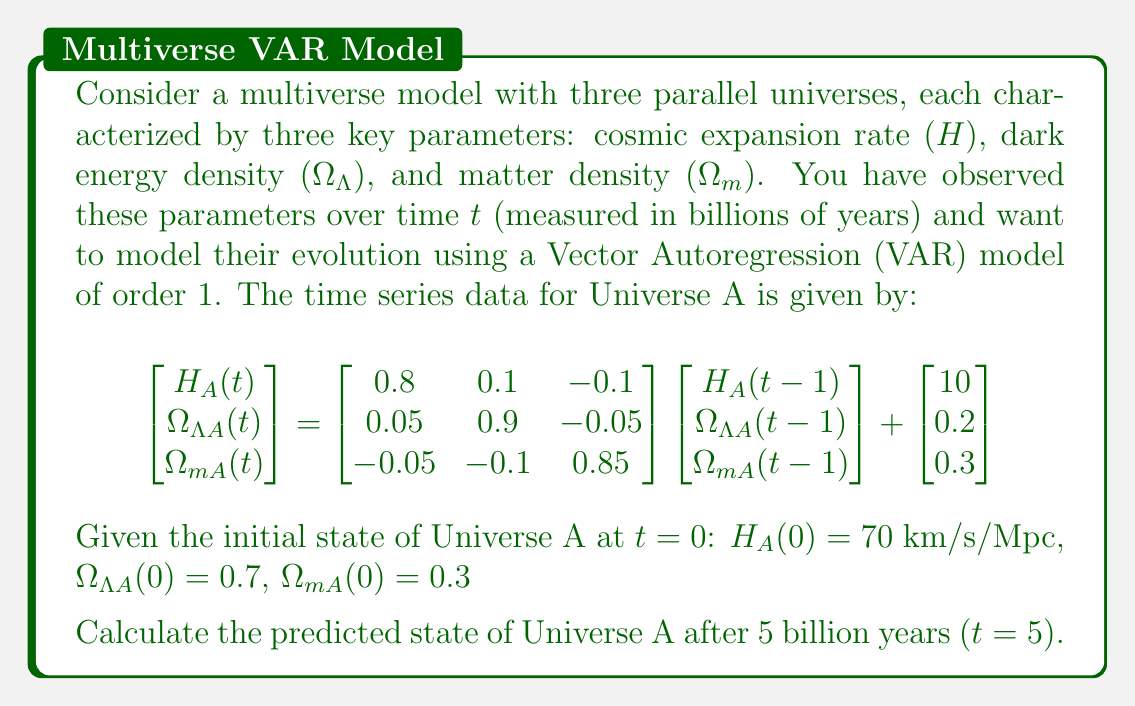Provide a solution to this math problem. To solve this problem, we need to iteratively apply the Vector Autoregression (VAR) model for 5 time steps. Let's break it down step-by-step:

1) First, let's define our matrices and vectors:

   $\mathbf{X}(t) = \begin{bmatrix} H_A(t) \\ \Omega_{\Lambda A}(t) \\ \Omega_{mA}(t) \end{bmatrix}$

   $\mathbf{A} = \begin{bmatrix} 0.8 & 0.1 & -0.1 \\ 0.05 & 0.9 & -0.05 \\ -0.05 & -0.1 & 0.85 \end{bmatrix}$

   $\mathbf{c} = \begin{bmatrix} 10 \\ 0.2 \\ 0.3 \end{bmatrix}$

2) The VAR(1) model is given by:
   
   $\mathbf{X}(t) = \mathbf{A}\mathbf{X}(t-1) + \mathbf{c}$

3) We start with $\mathbf{X}(0) = \begin{bmatrix} 70 \\ 0.7 \\ 0.3 \end{bmatrix}$

4) Now, let's calculate $\mathbf{X}(1)$:
   
   $\mathbf{X}(1) = \mathbf{A}\mathbf{X}(0) + \mathbf{c}$
   
   $= \begin{bmatrix} 0.8 & 0.1 & -0.1 \\ 0.05 & 0.9 & -0.05 \\ -0.05 & -0.1 & 0.85 \end{bmatrix} \begin{bmatrix} 70 \\ 0.7 \\ 0.3 \end{bmatrix} + \begin{bmatrix} 10 \\ 0.2 \\ 0.3 \end{bmatrix}$
   
   $= \begin{bmatrix} 66.37 \\ 0.8325 \\ 0.5425 \end{bmatrix}$

5) We continue this process for $t = 2, 3, 4, 5$:

   $\mathbf{X}(2) = \mathbf{A}\mathbf{X}(1) + \mathbf{c} = \begin{bmatrix} 63.7956 \\ 0.94925 \\ 0.74613 \end{bmatrix}$

   $\mathbf{X}(3) = \mathbf{A}\mathbf{X}(2) + \mathbf{c} = \begin{bmatrix} 62.0365 \\ 1.05166 \\ 0.91421 \end{bmatrix}$

   $\mathbf{X}(4) = \mathbf{A}\mathbf{X}(3) + \mathbf{c} = \begin{bmatrix} 60.9292 \\ 1.14149 \\ 1.05065 \end{bmatrix}$

   $\mathbf{X}(5) = \mathbf{A}\mathbf{X}(4) + \mathbf{c} = \begin{bmatrix} 60.3434 \\ 1.22034 \\ 1.16005 \end{bmatrix}$

6) Therefore, after 5 billion years:
   
   $H_A(5) \approx 60.3434$ km/s/Mpc
   $\Omega_{\Lambda A}(5) \approx 1.22034$
   $\Omega_{mA}(5) \approx 1.16005$
Answer: After 5 billion years, the predicted state of Universe A is:

$$\mathbf{X}(5) = \begin{bmatrix} H_A(5) \\ \Omega_{\Lambda A}(5) \\ \Omega_{mA}(5) \end{bmatrix} = \begin{bmatrix} 60.3434 \\ 1.22034 \\ 1.16005 \end{bmatrix}$$

Where $H_A(5)$ is measured in km/s/Mpc, and $\Omega_{\Lambda A}(5)$ and $\Omega_{mA}(5)$ are dimensionless. 